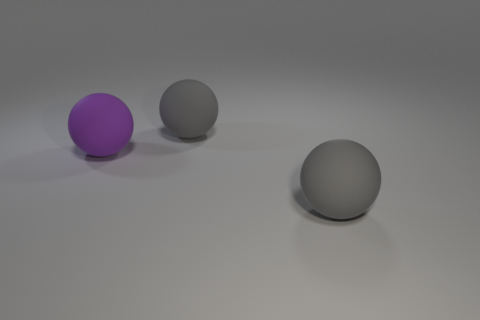There is a gray thing behind the gray sphere that is on the right side of the rubber sphere behind the purple thing; what is its size?
Offer a terse response. Large. Is there another purple ball made of the same material as the purple ball?
Give a very brief answer. No. Are the big gray ball behind the purple ball and the purple thing made of the same material?
Provide a short and direct response. Yes. What number of gray rubber things are there?
Provide a short and direct response. 2. The big matte thing behind the matte ball that is to the left of the big matte thing behind the purple rubber thing is what color?
Offer a very short reply. Gray. There is a large object behind the large purple object; what is its color?
Provide a short and direct response. Gray. There is a purple matte ball; how many big purple rubber objects are behind it?
Your answer should be very brief. 0. What number of objects are either big rubber things in front of the big purple matte sphere or small green metallic cylinders?
Provide a short and direct response. 1. Do the purple matte sphere and the matte object that is behind the big purple thing have the same size?
Make the answer very short. Yes. How many spheres are gray objects or rubber objects?
Your response must be concise. 3. 